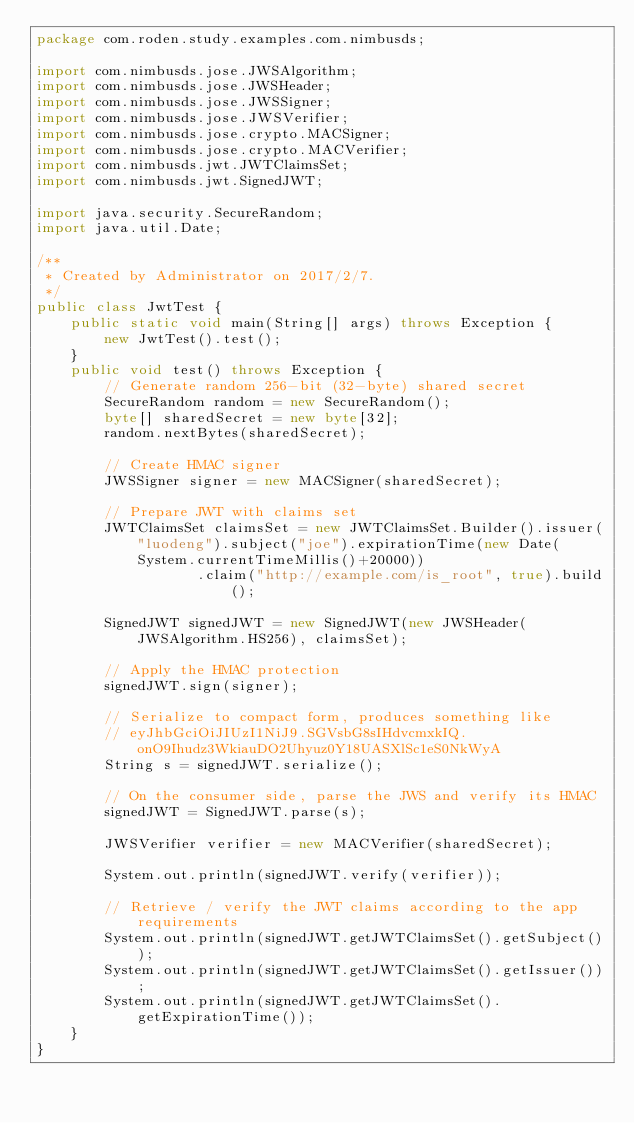<code> <loc_0><loc_0><loc_500><loc_500><_Java_>package com.roden.study.examples.com.nimbusds;

import com.nimbusds.jose.JWSAlgorithm;
import com.nimbusds.jose.JWSHeader;
import com.nimbusds.jose.JWSSigner;
import com.nimbusds.jose.JWSVerifier;
import com.nimbusds.jose.crypto.MACSigner;
import com.nimbusds.jose.crypto.MACVerifier;
import com.nimbusds.jwt.JWTClaimsSet;
import com.nimbusds.jwt.SignedJWT;

import java.security.SecureRandom;
import java.util.Date;

/**
 * Created by Administrator on 2017/2/7.
 */
public class JwtTest {
    public static void main(String[] args) throws Exception {
        new JwtTest().test();
    }
    public void test() throws Exception {
        // Generate random 256-bit (32-byte) shared secret
        SecureRandom random = new SecureRandom();
        byte[] sharedSecret = new byte[32];
        random.nextBytes(sharedSecret);

        // Create HMAC signer
        JWSSigner signer = new MACSigner(sharedSecret);

        // Prepare JWT with claims set
        JWTClaimsSet claimsSet = new JWTClaimsSet.Builder().issuer("luodeng").subject("joe").expirationTime(new Date(System.currentTimeMillis()+20000))
                   .claim("http://example.com/is_root", true).build();

        SignedJWT signedJWT = new SignedJWT(new JWSHeader(JWSAlgorithm.HS256), claimsSet);

        // Apply the HMAC protection
        signedJWT.sign(signer);

        // Serialize to compact form, produces something like
        // eyJhbGciOiJIUzI1NiJ9.SGVsbG8sIHdvcmxkIQ.onO9Ihudz3WkiauDO2Uhyuz0Y18UASXlSc1eS0NkWyA
        String s = signedJWT.serialize();

        // On the consumer side, parse the JWS and verify its HMAC
        signedJWT = SignedJWT.parse(s);

        JWSVerifier verifier = new MACVerifier(sharedSecret);

        System.out.println(signedJWT.verify(verifier));

        // Retrieve / verify the JWT claims according to the app requirements
        System.out.println(signedJWT.getJWTClaimsSet().getSubject());
        System.out.println(signedJWT.getJWTClaimsSet().getIssuer());
        System.out.println(signedJWT.getJWTClaimsSet().getExpirationTime());
    }
}
</code> 